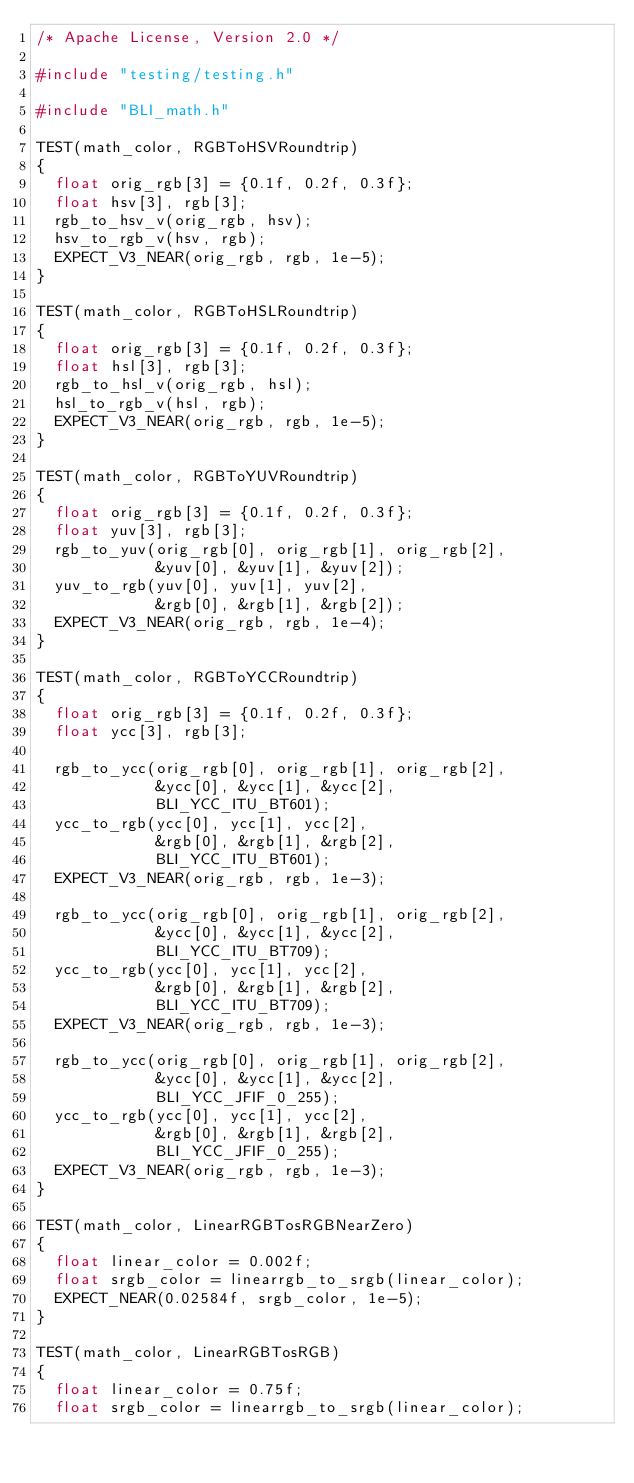<code> <loc_0><loc_0><loc_500><loc_500><_C++_>/* Apache License, Version 2.0 */

#include "testing/testing.h"

#include "BLI_math.h"

TEST(math_color, RGBToHSVRoundtrip)
{
	float orig_rgb[3] = {0.1f, 0.2f, 0.3f};
	float hsv[3], rgb[3];
	rgb_to_hsv_v(orig_rgb, hsv);
	hsv_to_rgb_v(hsv, rgb);
	EXPECT_V3_NEAR(orig_rgb, rgb, 1e-5);
}

TEST(math_color, RGBToHSLRoundtrip)
{
	float orig_rgb[3] = {0.1f, 0.2f, 0.3f};
	float hsl[3], rgb[3];
	rgb_to_hsl_v(orig_rgb, hsl);
	hsl_to_rgb_v(hsl, rgb);
	EXPECT_V3_NEAR(orig_rgb, rgb, 1e-5);
}

TEST(math_color, RGBToYUVRoundtrip)
{
	float orig_rgb[3] = {0.1f, 0.2f, 0.3f};
	float yuv[3], rgb[3];
	rgb_to_yuv(orig_rgb[0], orig_rgb[1], orig_rgb[2],
	           &yuv[0], &yuv[1], &yuv[2]);
	yuv_to_rgb(yuv[0], yuv[1], yuv[2],
	           &rgb[0], &rgb[1], &rgb[2]);
	EXPECT_V3_NEAR(orig_rgb, rgb, 1e-4);
}

TEST(math_color, RGBToYCCRoundtrip)
{
	float orig_rgb[3] = {0.1f, 0.2f, 0.3f};
	float ycc[3], rgb[3];

	rgb_to_ycc(orig_rgb[0], orig_rgb[1], orig_rgb[2],
	           &ycc[0], &ycc[1], &ycc[2],
	           BLI_YCC_ITU_BT601);
	ycc_to_rgb(ycc[0], ycc[1], ycc[2],
	           &rgb[0], &rgb[1], &rgb[2],
	           BLI_YCC_ITU_BT601);
	EXPECT_V3_NEAR(orig_rgb, rgb, 1e-3);

	rgb_to_ycc(orig_rgb[0], orig_rgb[1], orig_rgb[2],
	           &ycc[0], &ycc[1], &ycc[2],
	           BLI_YCC_ITU_BT709);
	ycc_to_rgb(ycc[0], ycc[1], ycc[2],
	           &rgb[0], &rgb[1], &rgb[2],
	           BLI_YCC_ITU_BT709);
	EXPECT_V3_NEAR(orig_rgb, rgb, 1e-3);

	rgb_to_ycc(orig_rgb[0], orig_rgb[1], orig_rgb[2],
	           &ycc[0], &ycc[1], &ycc[2],
	           BLI_YCC_JFIF_0_255);
	ycc_to_rgb(ycc[0], ycc[1], ycc[2],
	           &rgb[0], &rgb[1], &rgb[2],
	           BLI_YCC_JFIF_0_255);
	EXPECT_V3_NEAR(orig_rgb, rgb, 1e-3);
}

TEST(math_color, LinearRGBTosRGBNearZero)
{
	float linear_color = 0.002f;
	float srgb_color = linearrgb_to_srgb(linear_color);
	EXPECT_NEAR(0.02584f, srgb_color, 1e-5);
}

TEST(math_color, LinearRGBTosRGB)
{
	float linear_color = 0.75f;
	float srgb_color = linearrgb_to_srgb(linear_color);</code> 